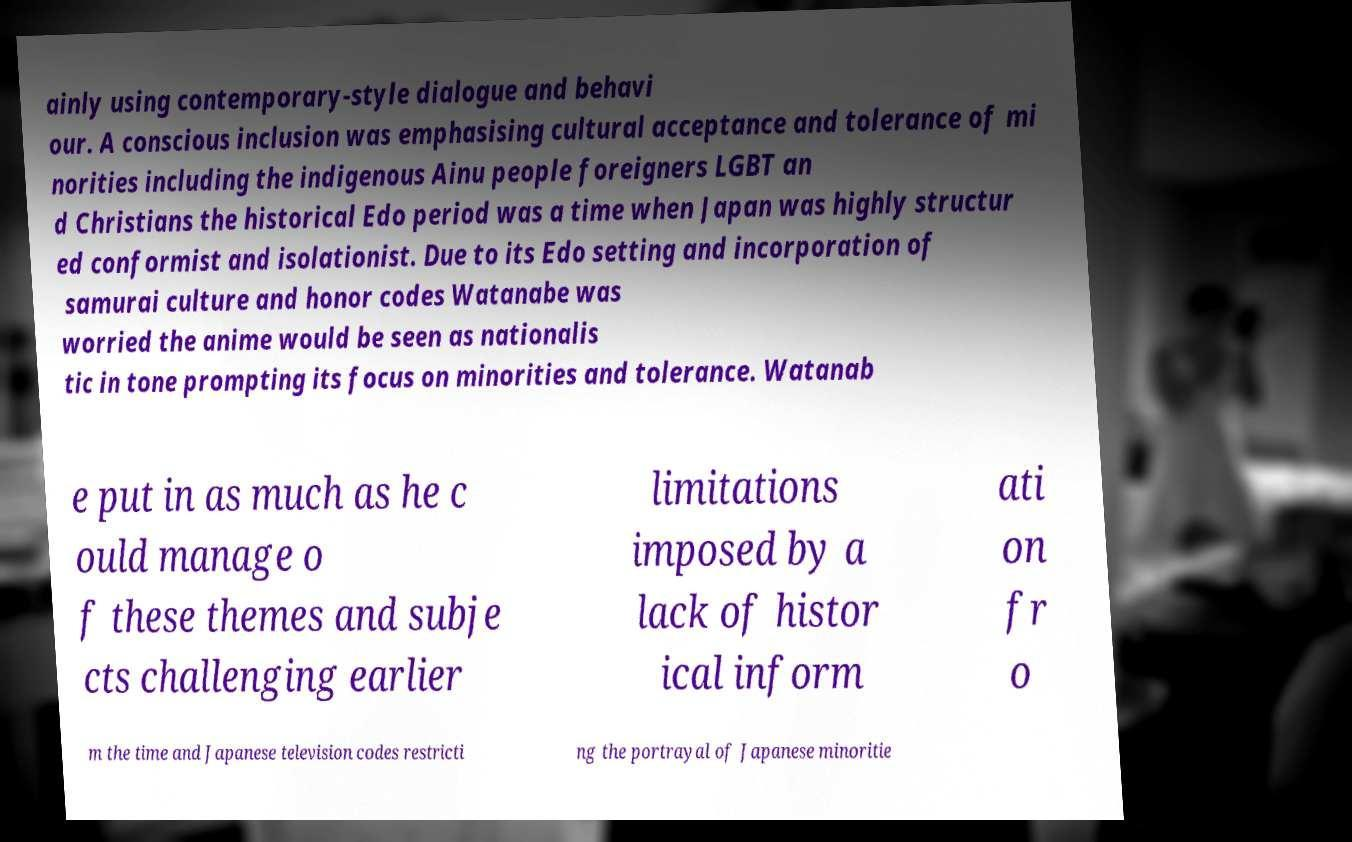Could you extract and type out the text from this image? ainly using contemporary-style dialogue and behavi our. A conscious inclusion was emphasising cultural acceptance and tolerance of mi norities including the indigenous Ainu people foreigners LGBT an d Christians the historical Edo period was a time when Japan was highly structur ed conformist and isolationist. Due to its Edo setting and incorporation of samurai culture and honor codes Watanabe was worried the anime would be seen as nationalis tic in tone prompting its focus on minorities and tolerance. Watanab e put in as much as he c ould manage o f these themes and subje cts challenging earlier limitations imposed by a lack of histor ical inform ati on fr o m the time and Japanese television codes restricti ng the portrayal of Japanese minoritie 